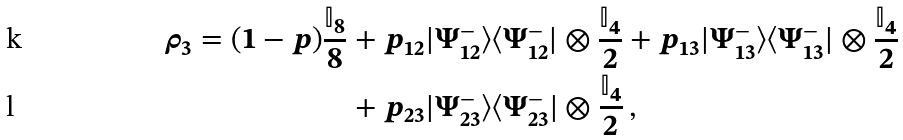<formula> <loc_0><loc_0><loc_500><loc_500>\rho _ { 3 } = ( 1 - p ) \frac { \mathbb { I } _ { 8 } } { 8 } & + p _ { 1 2 } | \Psi _ { 1 2 } ^ { - } \rangle \langle \Psi _ { 1 2 } ^ { - } | \otimes \frac { \mathbb { I } _ { 4 } } { 2 } + p _ { 1 3 } | \Psi _ { 1 3 } ^ { - } \rangle \langle \Psi _ { 1 3 } ^ { - } | \otimes \frac { \mathbb { I } _ { 4 } } { 2 } \\ & + p _ { 2 3 } | \Psi _ { 2 3 } ^ { - } \rangle \langle \Psi _ { 2 3 } ^ { - } | \otimes \frac { \mathbb { I } _ { 4 } } { 2 } \, ,</formula> 